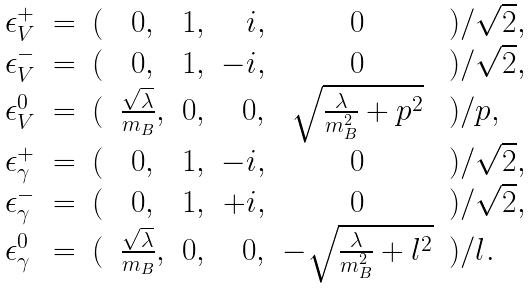Convert formula to latex. <formula><loc_0><loc_0><loc_500><loc_500>\begin{array} { l c l c c r c l } \epsilon _ { V } ^ { + } & = & ( & 0 , & 1 , & i , & 0 & ) / \sqrt { 2 } , \\ \epsilon _ { V } ^ { - } & = & ( & 0 , & 1 , & - i , & 0 & ) / \sqrt { 2 } , \\ \epsilon _ { V } ^ { 0 } & = & ( & \frac { \sqrt { \lambda } } { m _ { B } } , & 0 , & 0 , & \sqrt { \frac { \lambda } { m _ { B } ^ { 2 } } + p ^ { 2 } } & ) / p , \\ \epsilon _ { \gamma } ^ { + } & = & ( & 0 , & 1 , & - i , & 0 & ) / \sqrt { 2 } , \\ \epsilon _ { \gamma } ^ { - } & = & ( & 0 , & 1 , & + i , & 0 & ) / \sqrt { 2 } , \\ \epsilon _ { \gamma } ^ { 0 } & = & ( & \frac { \sqrt { \lambda } } { m _ { B } } , & 0 , & 0 , & - \sqrt { \frac { \lambda } { m _ { B } ^ { 2 } } + l ^ { 2 } } & ) / l . \end{array}</formula> 